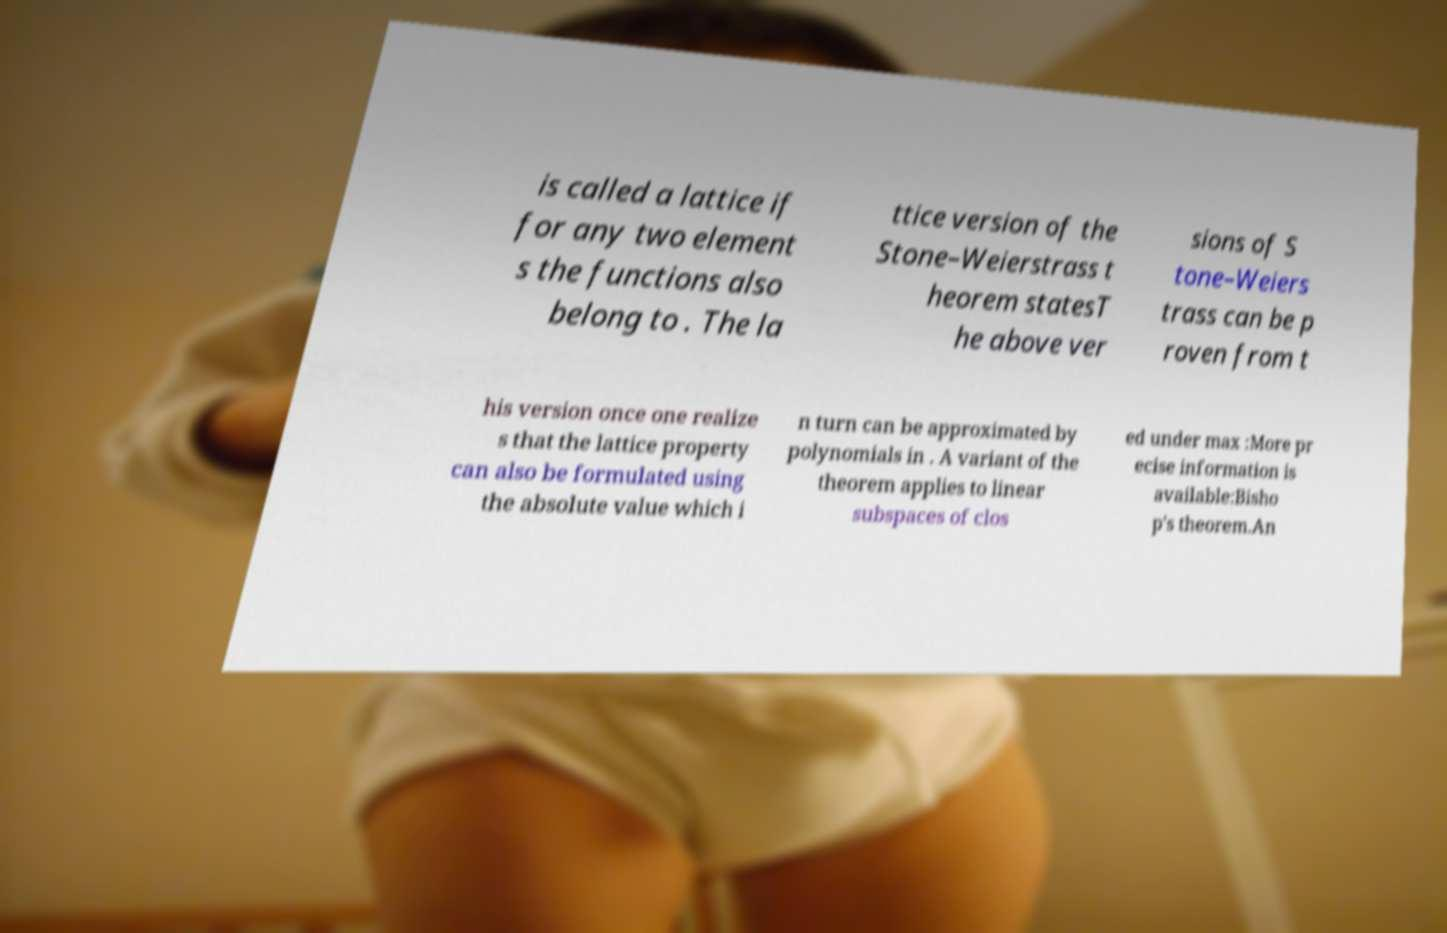I need the written content from this picture converted into text. Can you do that? is called a lattice if for any two element s the functions also belong to . The la ttice version of the Stone–Weierstrass t heorem statesT he above ver sions of S tone–Weiers trass can be p roven from t his version once one realize s that the lattice property can also be formulated using the absolute value which i n turn can be approximated by polynomials in . A variant of the theorem applies to linear subspaces of clos ed under max :More pr ecise information is available:Bisho p's theorem.An 